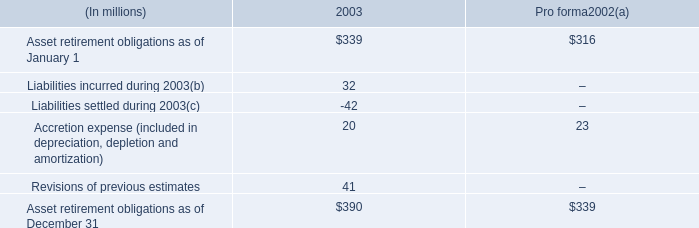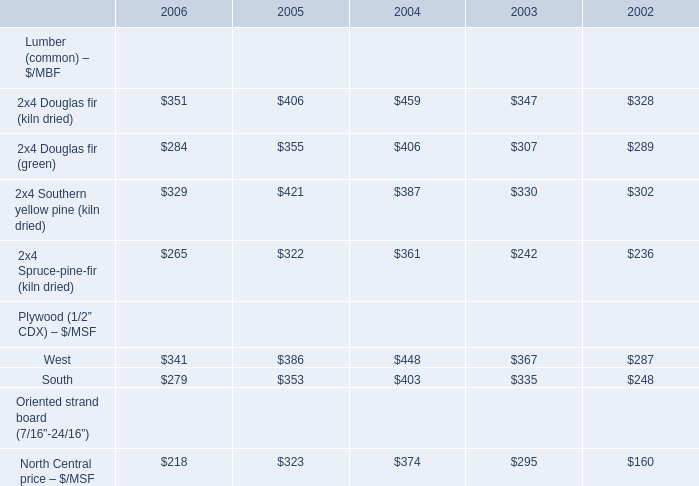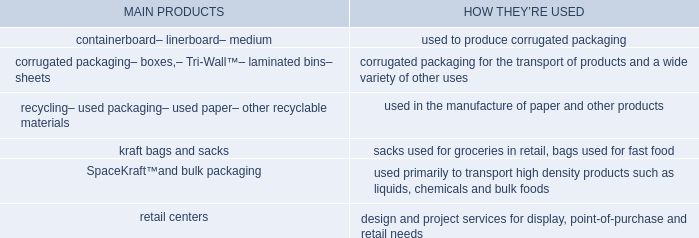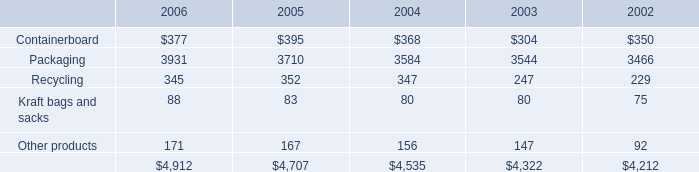What is the sum of the 2x4 Spruce-pine-fir (kiln dried) in the years where 2x4 Douglas fir (kiln dried) greater than 400? 
Computations: (322 + 361)
Answer: 683.0. 